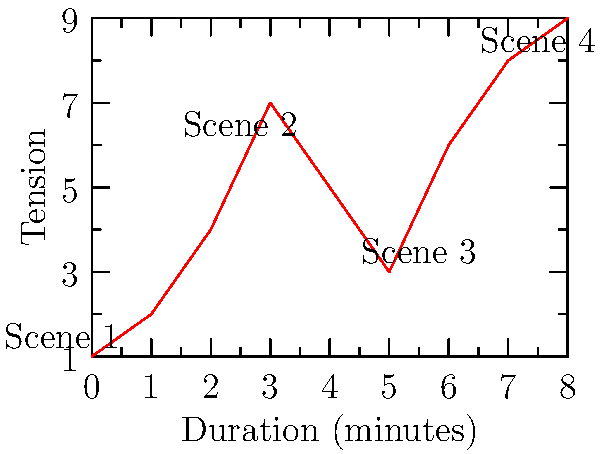In a Bollywood thriller, a screenwriter has plotted the tension levels of different scenes against their duration. The graph shows the tension progression over time. If the director wants to maintain a consistent rise in tension, at which minute marks should the transitions between scenes occur to achieve maximum impact? To determine the ideal transition points for maximum impact, we need to analyze the graph and identify the local maxima of tension:

1. Scene 1 to Scene 2: The tension rises steadily from 0 to 3 minutes, reaching a local maximum at the 3-minute mark with a tension level of 7.

2. Scene 2 to Scene 3: After the peak at 3 minutes, tension drops and then rises again. The next local maximum occurs at the 5-minute mark with a tension level of 6.

3. Scene 3 to Scene 4: Following the dip after 5 minutes, tension rises sharply. The final peak shown on the graph is at the 8-minute mark with a tension level of 9.

To maintain a consistent rise in tension and achieve maximum impact, the screenwriter should place the transitions at these local maxima points. This ensures that each scene ends on a high note of tension, creating a compelling narrative flow.

Therefore, the ideal transition points are at 3 minutes, 5 minutes, and 8 minutes.
Answer: 3, 5, and 8 minutes 